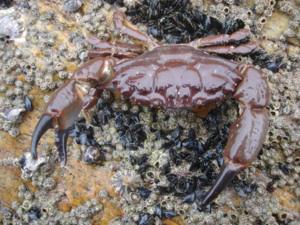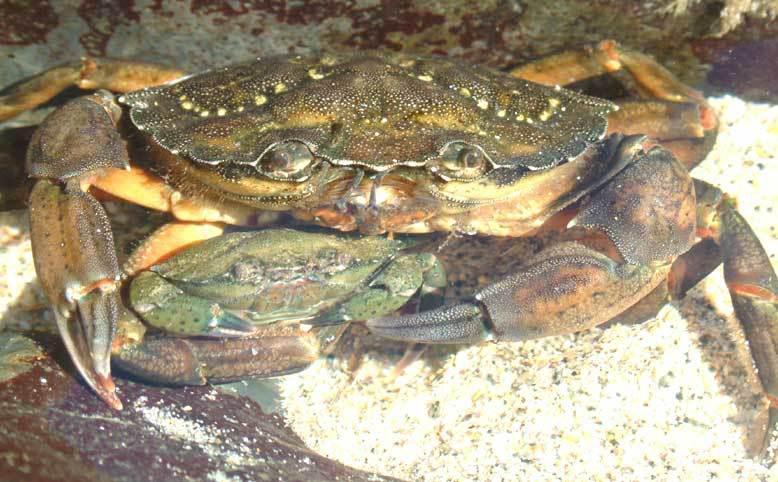The first image is the image on the left, the second image is the image on the right. Considering the images on both sides, is "IN at least one image there is at least one blue clawed crab sitting on a wooden dock." valid? Answer yes or no. No. 